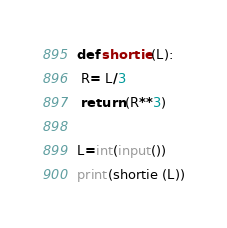Convert code to text. <code><loc_0><loc_0><loc_500><loc_500><_Python_>def shortie (L):
 R= L/3
 return (R**3)

L=int(input())
print(shortie (L))</code> 